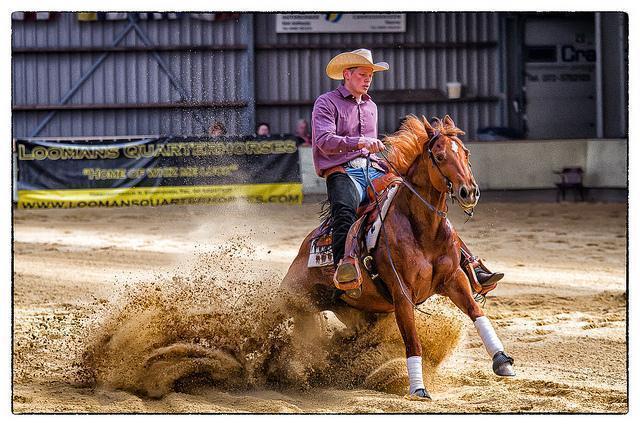What mythological creature is most similar to the one the man is riding on?
Choose the right answer from the provided options to respond to the question.
Options: Phlegon, medusa, cerberus, airavata. Phlegon. 